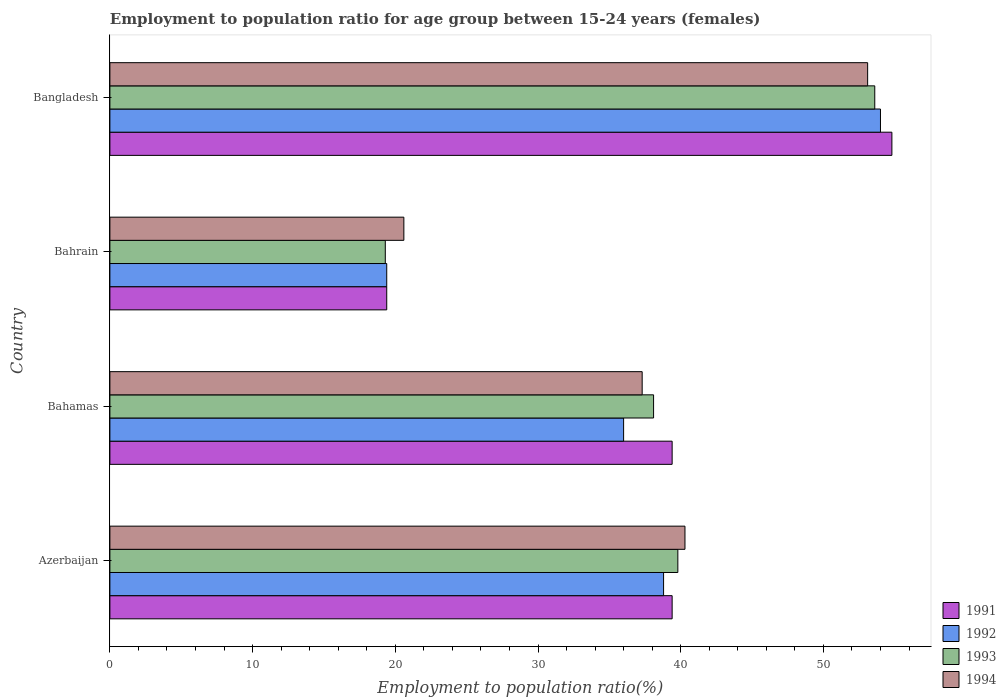How many groups of bars are there?
Offer a terse response. 4. Are the number of bars per tick equal to the number of legend labels?
Your answer should be very brief. Yes. How many bars are there on the 2nd tick from the bottom?
Offer a terse response. 4. What is the label of the 3rd group of bars from the top?
Make the answer very short. Bahamas. In how many cases, is the number of bars for a given country not equal to the number of legend labels?
Provide a succinct answer. 0. What is the employment to population ratio in 1991 in Bahrain?
Your response must be concise. 19.4. Across all countries, what is the maximum employment to population ratio in 1994?
Ensure brevity in your answer.  53.1. Across all countries, what is the minimum employment to population ratio in 1993?
Your answer should be compact. 19.3. In which country was the employment to population ratio in 1993 minimum?
Ensure brevity in your answer.  Bahrain. What is the total employment to population ratio in 1994 in the graph?
Offer a terse response. 151.3. What is the difference between the employment to population ratio in 1993 in Bahamas and that in Bahrain?
Ensure brevity in your answer.  18.8. What is the difference between the employment to population ratio in 1993 in Bahrain and the employment to population ratio in 1992 in Bangladesh?
Offer a terse response. -34.7. What is the average employment to population ratio in 1992 per country?
Make the answer very short. 37.05. What is the difference between the employment to population ratio in 1992 and employment to population ratio in 1994 in Azerbaijan?
Offer a very short reply. -1.5. In how many countries, is the employment to population ratio in 1994 greater than 14 %?
Offer a terse response. 4. What is the ratio of the employment to population ratio in 1991 in Azerbaijan to that in Bahamas?
Offer a very short reply. 1. What is the difference between the highest and the second highest employment to population ratio in 1994?
Give a very brief answer. 12.8. What is the difference between the highest and the lowest employment to population ratio in 1993?
Offer a terse response. 34.3. In how many countries, is the employment to population ratio in 1994 greater than the average employment to population ratio in 1994 taken over all countries?
Your response must be concise. 2. Is the sum of the employment to population ratio in 1994 in Bahrain and Bangladesh greater than the maximum employment to population ratio in 1991 across all countries?
Your response must be concise. Yes. Is it the case that in every country, the sum of the employment to population ratio in 1994 and employment to population ratio in 1992 is greater than the sum of employment to population ratio in 1991 and employment to population ratio in 1993?
Keep it short and to the point. No. How many bars are there?
Make the answer very short. 16. How many countries are there in the graph?
Your answer should be compact. 4. Does the graph contain any zero values?
Keep it short and to the point. No. Where does the legend appear in the graph?
Ensure brevity in your answer.  Bottom right. What is the title of the graph?
Give a very brief answer. Employment to population ratio for age group between 15-24 years (females). Does "1979" appear as one of the legend labels in the graph?
Ensure brevity in your answer.  No. What is the label or title of the Y-axis?
Provide a succinct answer. Country. What is the Employment to population ratio(%) in 1991 in Azerbaijan?
Provide a succinct answer. 39.4. What is the Employment to population ratio(%) of 1992 in Azerbaijan?
Provide a short and direct response. 38.8. What is the Employment to population ratio(%) of 1993 in Azerbaijan?
Offer a very short reply. 39.8. What is the Employment to population ratio(%) of 1994 in Azerbaijan?
Offer a terse response. 40.3. What is the Employment to population ratio(%) in 1991 in Bahamas?
Give a very brief answer. 39.4. What is the Employment to population ratio(%) in 1992 in Bahamas?
Ensure brevity in your answer.  36. What is the Employment to population ratio(%) of 1993 in Bahamas?
Ensure brevity in your answer.  38.1. What is the Employment to population ratio(%) of 1994 in Bahamas?
Keep it short and to the point. 37.3. What is the Employment to population ratio(%) in 1991 in Bahrain?
Your response must be concise. 19.4. What is the Employment to population ratio(%) in 1992 in Bahrain?
Keep it short and to the point. 19.4. What is the Employment to population ratio(%) of 1993 in Bahrain?
Your response must be concise. 19.3. What is the Employment to population ratio(%) of 1994 in Bahrain?
Your answer should be compact. 20.6. What is the Employment to population ratio(%) of 1991 in Bangladesh?
Provide a short and direct response. 54.8. What is the Employment to population ratio(%) in 1993 in Bangladesh?
Provide a short and direct response. 53.6. What is the Employment to population ratio(%) in 1994 in Bangladesh?
Offer a terse response. 53.1. Across all countries, what is the maximum Employment to population ratio(%) in 1991?
Keep it short and to the point. 54.8. Across all countries, what is the maximum Employment to population ratio(%) in 1993?
Your answer should be compact. 53.6. Across all countries, what is the maximum Employment to population ratio(%) in 1994?
Make the answer very short. 53.1. Across all countries, what is the minimum Employment to population ratio(%) in 1991?
Your response must be concise. 19.4. Across all countries, what is the minimum Employment to population ratio(%) of 1992?
Your answer should be compact. 19.4. Across all countries, what is the minimum Employment to population ratio(%) of 1993?
Ensure brevity in your answer.  19.3. Across all countries, what is the minimum Employment to population ratio(%) in 1994?
Your answer should be compact. 20.6. What is the total Employment to population ratio(%) of 1991 in the graph?
Your response must be concise. 153. What is the total Employment to population ratio(%) in 1992 in the graph?
Provide a short and direct response. 148.2. What is the total Employment to population ratio(%) of 1993 in the graph?
Your answer should be compact. 150.8. What is the total Employment to population ratio(%) in 1994 in the graph?
Give a very brief answer. 151.3. What is the difference between the Employment to population ratio(%) of 1993 in Azerbaijan and that in Bahamas?
Your response must be concise. 1.7. What is the difference between the Employment to population ratio(%) of 1994 in Azerbaijan and that in Bahamas?
Your answer should be very brief. 3. What is the difference between the Employment to population ratio(%) of 1991 in Azerbaijan and that in Bahrain?
Ensure brevity in your answer.  20. What is the difference between the Employment to population ratio(%) of 1991 in Azerbaijan and that in Bangladesh?
Offer a terse response. -15.4. What is the difference between the Employment to population ratio(%) of 1992 in Azerbaijan and that in Bangladesh?
Offer a very short reply. -15.2. What is the difference between the Employment to population ratio(%) of 1991 in Bahamas and that in Bangladesh?
Your answer should be very brief. -15.4. What is the difference between the Employment to population ratio(%) of 1993 in Bahamas and that in Bangladesh?
Your answer should be very brief. -15.5. What is the difference between the Employment to population ratio(%) of 1994 in Bahamas and that in Bangladesh?
Your answer should be compact. -15.8. What is the difference between the Employment to population ratio(%) of 1991 in Bahrain and that in Bangladesh?
Keep it short and to the point. -35.4. What is the difference between the Employment to population ratio(%) in 1992 in Bahrain and that in Bangladesh?
Your response must be concise. -34.6. What is the difference between the Employment to population ratio(%) in 1993 in Bahrain and that in Bangladesh?
Offer a terse response. -34.3. What is the difference between the Employment to population ratio(%) of 1994 in Bahrain and that in Bangladesh?
Offer a terse response. -32.5. What is the difference between the Employment to population ratio(%) in 1991 in Azerbaijan and the Employment to population ratio(%) in 1992 in Bahamas?
Your answer should be compact. 3.4. What is the difference between the Employment to population ratio(%) in 1992 in Azerbaijan and the Employment to population ratio(%) in 1993 in Bahamas?
Offer a terse response. 0.7. What is the difference between the Employment to population ratio(%) of 1992 in Azerbaijan and the Employment to population ratio(%) of 1994 in Bahamas?
Provide a short and direct response. 1.5. What is the difference between the Employment to population ratio(%) in 1993 in Azerbaijan and the Employment to population ratio(%) in 1994 in Bahamas?
Keep it short and to the point. 2.5. What is the difference between the Employment to population ratio(%) of 1991 in Azerbaijan and the Employment to population ratio(%) of 1992 in Bahrain?
Your answer should be compact. 20. What is the difference between the Employment to population ratio(%) in 1991 in Azerbaijan and the Employment to population ratio(%) in 1993 in Bahrain?
Provide a succinct answer. 20.1. What is the difference between the Employment to population ratio(%) in 1991 in Azerbaijan and the Employment to population ratio(%) in 1994 in Bahrain?
Ensure brevity in your answer.  18.8. What is the difference between the Employment to population ratio(%) of 1992 in Azerbaijan and the Employment to population ratio(%) of 1993 in Bahrain?
Ensure brevity in your answer.  19.5. What is the difference between the Employment to population ratio(%) in 1991 in Azerbaijan and the Employment to population ratio(%) in 1992 in Bangladesh?
Make the answer very short. -14.6. What is the difference between the Employment to population ratio(%) in 1991 in Azerbaijan and the Employment to population ratio(%) in 1993 in Bangladesh?
Give a very brief answer. -14.2. What is the difference between the Employment to population ratio(%) of 1991 in Azerbaijan and the Employment to population ratio(%) of 1994 in Bangladesh?
Provide a succinct answer. -13.7. What is the difference between the Employment to population ratio(%) of 1992 in Azerbaijan and the Employment to population ratio(%) of 1993 in Bangladesh?
Give a very brief answer. -14.8. What is the difference between the Employment to population ratio(%) in 1992 in Azerbaijan and the Employment to population ratio(%) in 1994 in Bangladesh?
Your answer should be very brief. -14.3. What is the difference between the Employment to population ratio(%) of 1991 in Bahamas and the Employment to population ratio(%) of 1993 in Bahrain?
Ensure brevity in your answer.  20.1. What is the difference between the Employment to population ratio(%) in 1991 in Bahamas and the Employment to population ratio(%) in 1994 in Bahrain?
Provide a succinct answer. 18.8. What is the difference between the Employment to population ratio(%) in 1992 in Bahamas and the Employment to population ratio(%) in 1994 in Bahrain?
Your answer should be very brief. 15.4. What is the difference between the Employment to population ratio(%) in 1991 in Bahamas and the Employment to population ratio(%) in 1992 in Bangladesh?
Offer a very short reply. -14.6. What is the difference between the Employment to population ratio(%) in 1991 in Bahamas and the Employment to population ratio(%) in 1993 in Bangladesh?
Keep it short and to the point. -14.2. What is the difference between the Employment to population ratio(%) in 1991 in Bahamas and the Employment to population ratio(%) in 1994 in Bangladesh?
Ensure brevity in your answer.  -13.7. What is the difference between the Employment to population ratio(%) in 1992 in Bahamas and the Employment to population ratio(%) in 1993 in Bangladesh?
Provide a succinct answer. -17.6. What is the difference between the Employment to population ratio(%) of 1992 in Bahamas and the Employment to population ratio(%) of 1994 in Bangladesh?
Give a very brief answer. -17.1. What is the difference between the Employment to population ratio(%) of 1993 in Bahamas and the Employment to population ratio(%) of 1994 in Bangladesh?
Make the answer very short. -15. What is the difference between the Employment to population ratio(%) of 1991 in Bahrain and the Employment to population ratio(%) of 1992 in Bangladesh?
Ensure brevity in your answer.  -34.6. What is the difference between the Employment to population ratio(%) in 1991 in Bahrain and the Employment to population ratio(%) in 1993 in Bangladesh?
Keep it short and to the point. -34.2. What is the difference between the Employment to population ratio(%) in 1991 in Bahrain and the Employment to population ratio(%) in 1994 in Bangladesh?
Offer a terse response. -33.7. What is the difference between the Employment to population ratio(%) of 1992 in Bahrain and the Employment to population ratio(%) of 1993 in Bangladesh?
Your response must be concise. -34.2. What is the difference between the Employment to population ratio(%) in 1992 in Bahrain and the Employment to population ratio(%) in 1994 in Bangladesh?
Provide a succinct answer. -33.7. What is the difference between the Employment to population ratio(%) of 1993 in Bahrain and the Employment to population ratio(%) of 1994 in Bangladesh?
Offer a very short reply. -33.8. What is the average Employment to population ratio(%) of 1991 per country?
Your answer should be very brief. 38.25. What is the average Employment to population ratio(%) of 1992 per country?
Provide a short and direct response. 37.05. What is the average Employment to population ratio(%) in 1993 per country?
Give a very brief answer. 37.7. What is the average Employment to population ratio(%) of 1994 per country?
Ensure brevity in your answer.  37.83. What is the difference between the Employment to population ratio(%) in 1991 and Employment to population ratio(%) in 1992 in Azerbaijan?
Make the answer very short. 0.6. What is the difference between the Employment to population ratio(%) of 1991 and Employment to population ratio(%) of 1994 in Azerbaijan?
Offer a very short reply. -0.9. What is the difference between the Employment to population ratio(%) in 1992 and Employment to population ratio(%) in 1993 in Azerbaijan?
Your response must be concise. -1. What is the difference between the Employment to population ratio(%) in 1992 and Employment to population ratio(%) in 1994 in Azerbaijan?
Ensure brevity in your answer.  -1.5. What is the difference between the Employment to population ratio(%) of 1993 and Employment to population ratio(%) of 1994 in Azerbaijan?
Your answer should be compact. -0.5. What is the difference between the Employment to population ratio(%) in 1991 and Employment to population ratio(%) in 1992 in Bahamas?
Your answer should be very brief. 3.4. What is the difference between the Employment to population ratio(%) in 1991 and Employment to population ratio(%) in 1993 in Bahamas?
Offer a terse response. 1.3. What is the difference between the Employment to population ratio(%) of 1991 and Employment to population ratio(%) of 1994 in Bahamas?
Offer a very short reply. 2.1. What is the difference between the Employment to population ratio(%) in 1992 and Employment to population ratio(%) in 1993 in Bahamas?
Give a very brief answer. -2.1. What is the difference between the Employment to population ratio(%) in 1992 and Employment to population ratio(%) in 1994 in Bahamas?
Make the answer very short. -1.3. What is the difference between the Employment to population ratio(%) in 1993 and Employment to population ratio(%) in 1994 in Bahamas?
Provide a short and direct response. 0.8. What is the difference between the Employment to population ratio(%) of 1991 and Employment to population ratio(%) of 1992 in Bahrain?
Your answer should be compact. 0. What is the difference between the Employment to population ratio(%) of 1992 and Employment to population ratio(%) of 1994 in Bahrain?
Your answer should be compact. -1.2. What is the difference between the Employment to population ratio(%) in 1993 and Employment to population ratio(%) in 1994 in Bahrain?
Your answer should be compact. -1.3. What is the difference between the Employment to population ratio(%) in 1991 and Employment to population ratio(%) in 1994 in Bangladesh?
Offer a terse response. 1.7. What is the difference between the Employment to population ratio(%) of 1993 and Employment to population ratio(%) of 1994 in Bangladesh?
Offer a terse response. 0.5. What is the ratio of the Employment to population ratio(%) of 1991 in Azerbaijan to that in Bahamas?
Offer a very short reply. 1. What is the ratio of the Employment to population ratio(%) in 1992 in Azerbaijan to that in Bahamas?
Give a very brief answer. 1.08. What is the ratio of the Employment to population ratio(%) of 1993 in Azerbaijan to that in Bahamas?
Offer a very short reply. 1.04. What is the ratio of the Employment to population ratio(%) in 1994 in Azerbaijan to that in Bahamas?
Make the answer very short. 1.08. What is the ratio of the Employment to population ratio(%) of 1991 in Azerbaijan to that in Bahrain?
Offer a very short reply. 2.03. What is the ratio of the Employment to population ratio(%) in 1993 in Azerbaijan to that in Bahrain?
Keep it short and to the point. 2.06. What is the ratio of the Employment to population ratio(%) in 1994 in Azerbaijan to that in Bahrain?
Keep it short and to the point. 1.96. What is the ratio of the Employment to population ratio(%) in 1991 in Azerbaijan to that in Bangladesh?
Your answer should be compact. 0.72. What is the ratio of the Employment to population ratio(%) of 1992 in Azerbaijan to that in Bangladesh?
Provide a succinct answer. 0.72. What is the ratio of the Employment to population ratio(%) of 1993 in Azerbaijan to that in Bangladesh?
Make the answer very short. 0.74. What is the ratio of the Employment to population ratio(%) of 1994 in Azerbaijan to that in Bangladesh?
Offer a very short reply. 0.76. What is the ratio of the Employment to population ratio(%) in 1991 in Bahamas to that in Bahrain?
Keep it short and to the point. 2.03. What is the ratio of the Employment to population ratio(%) of 1992 in Bahamas to that in Bahrain?
Ensure brevity in your answer.  1.86. What is the ratio of the Employment to population ratio(%) of 1993 in Bahamas to that in Bahrain?
Offer a terse response. 1.97. What is the ratio of the Employment to population ratio(%) of 1994 in Bahamas to that in Bahrain?
Give a very brief answer. 1.81. What is the ratio of the Employment to population ratio(%) of 1991 in Bahamas to that in Bangladesh?
Ensure brevity in your answer.  0.72. What is the ratio of the Employment to population ratio(%) of 1993 in Bahamas to that in Bangladesh?
Provide a succinct answer. 0.71. What is the ratio of the Employment to population ratio(%) in 1994 in Bahamas to that in Bangladesh?
Make the answer very short. 0.7. What is the ratio of the Employment to population ratio(%) of 1991 in Bahrain to that in Bangladesh?
Your answer should be compact. 0.35. What is the ratio of the Employment to population ratio(%) in 1992 in Bahrain to that in Bangladesh?
Ensure brevity in your answer.  0.36. What is the ratio of the Employment to population ratio(%) in 1993 in Bahrain to that in Bangladesh?
Your answer should be compact. 0.36. What is the ratio of the Employment to population ratio(%) of 1994 in Bahrain to that in Bangladesh?
Provide a succinct answer. 0.39. What is the difference between the highest and the second highest Employment to population ratio(%) in 1993?
Ensure brevity in your answer.  13.8. What is the difference between the highest and the lowest Employment to population ratio(%) of 1991?
Offer a terse response. 35.4. What is the difference between the highest and the lowest Employment to population ratio(%) in 1992?
Offer a very short reply. 34.6. What is the difference between the highest and the lowest Employment to population ratio(%) in 1993?
Your answer should be very brief. 34.3. What is the difference between the highest and the lowest Employment to population ratio(%) in 1994?
Your answer should be compact. 32.5. 